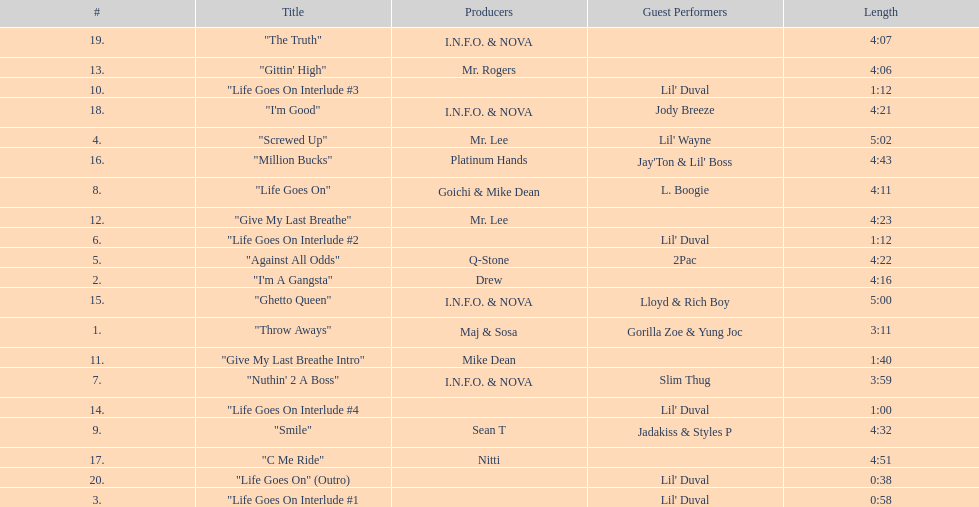How many tracks on trae's album "life goes on"? 20. 